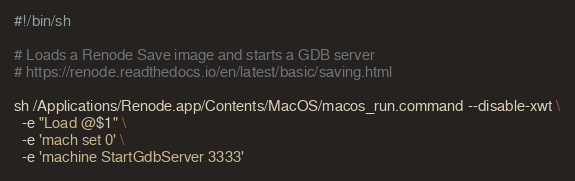<code> <loc_0><loc_0><loc_500><loc_500><_Bash_>#!/bin/sh

# Loads a Renode Save image and starts a GDB server
# https://renode.readthedocs.io/en/latest/basic/saving.html

sh /Applications/Renode.app/Contents/MacOS/macos_run.command --disable-xwt \
  -e "Load @$1" \
  -e 'mach set 0' \
  -e 'machine StartGdbServer 3333'
</code> 